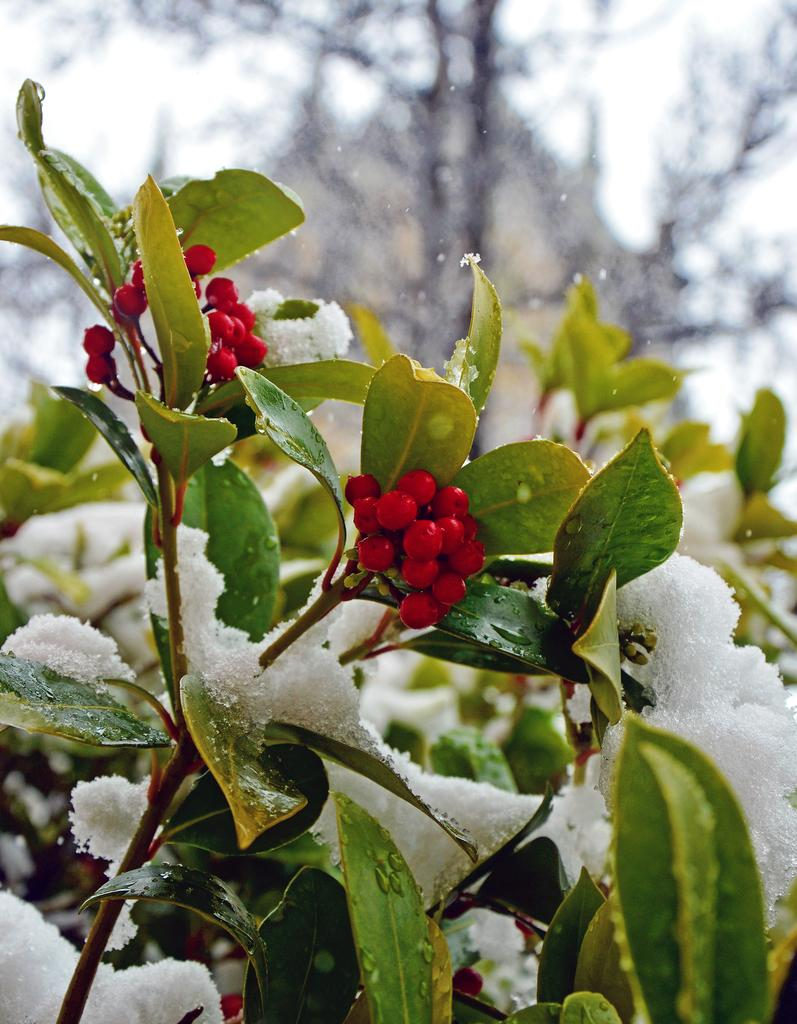What type of plant is depicted in the image? The image shows fruits of a plant, but it does not specify the type of plant. How are the fruits of the plant affected in the image? The fruits are covered with snow in the image. What type of apples are depicted in the image? The image does not show apples; it shows fruits covered with snow, but the specific type of fruit is not mentioned. What type of steel is visible in the image? There is no steel present in the image. 